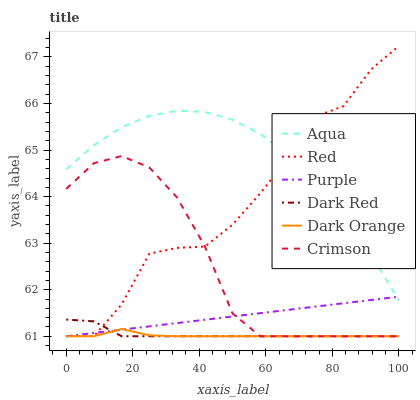Does Dark Orange have the minimum area under the curve?
Answer yes or no. Yes. Does Aqua have the maximum area under the curve?
Answer yes or no. Yes. Does Purple have the minimum area under the curve?
Answer yes or no. No. Does Purple have the maximum area under the curve?
Answer yes or no. No. Is Purple the smoothest?
Answer yes or no. Yes. Is Red the roughest?
Answer yes or no. Yes. Is Dark Red the smoothest?
Answer yes or no. No. Is Dark Red the roughest?
Answer yes or no. No. Does Dark Orange have the lowest value?
Answer yes or no. Yes. Does Aqua have the lowest value?
Answer yes or no. No. Does Red have the highest value?
Answer yes or no. Yes. Does Purple have the highest value?
Answer yes or no. No. Is Dark Red less than Aqua?
Answer yes or no. Yes. Is Aqua greater than Dark Red?
Answer yes or no. Yes. Does Purple intersect Crimson?
Answer yes or no. Yes. Is Purple less than Crimson?
Answer yes or no. No. Is Purple greater than Crimson?
Answer yes or no. No. Does Dark Red intersect Aqua?
Answer yes or no. No. 